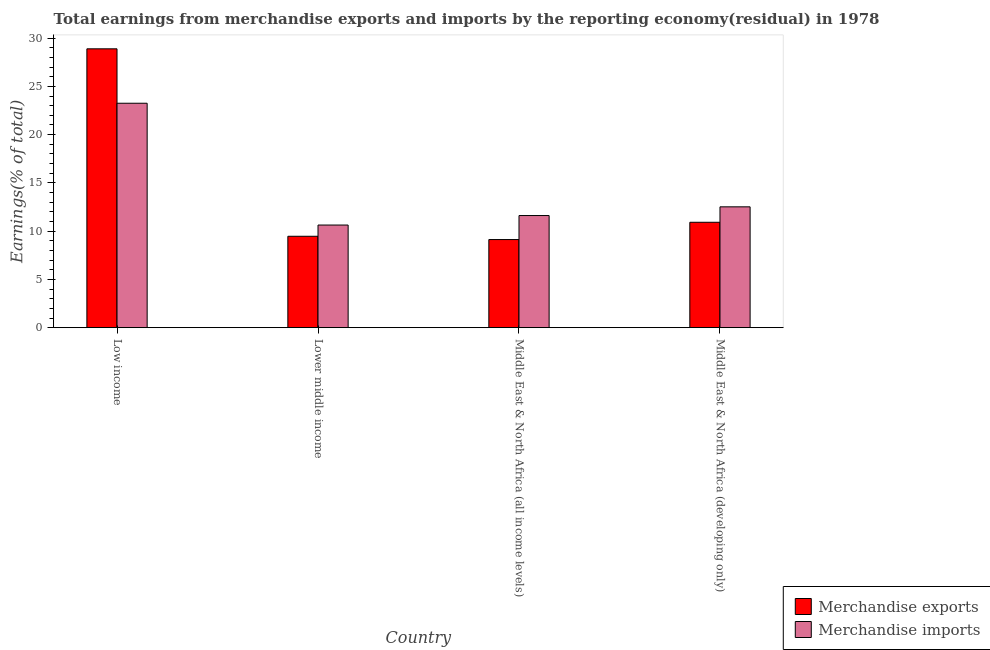How many different coloured bars are there?
Offer a terse response. 2. Are the number of bars per tick equal to the number of legend labels?
Your answer should be compact. Yes. How many bars are there on the 4th tick from the left?
Offer a very short reply. 2. How many bars are there on the 2nd tick from the right?
Your response must be concise. 2. What is the label of the 3rd group of bars from the left?
Your answer should be compact. Middle East & North Africa (all income levels). In how many cases, is the number of bars for a given country not equal to the number of legend labels?
Provide a succinct answer. 0. What is the earnings from merchandise exports in Middle East & North Africa (all income levels)?
Offer a very short reply. 9.13. Across all countries, what is the maximum earnings from merchandise exports?
Keep it short and to the point. 28.89. Across all countries, what is the minimum earnings from merchandise exports?
Your answer should be compact. 9.13. In which country was the earnings from merchandise imports maximum?
Your answer should be compact. Low income. In which country was the earnings from merchandise exports minimum?
Offer a very short reply. Middle East & North Africa (all income levels). What is the total earnings from merchandise imports in the graph?
Keep it short and to the point. 58.02. What is the difference between the earnings from merchandise exports in Lower middle income and that in Middle East & North Africa (developing only)?
Provide a short and direct response. -1.45. What is the difference between the earnings from merchandise imports in Lower middle income and the earnings from merchandise exports in Middle East & North Africa (all income levels)?
Ensure brevity in your answer.  1.5. What is the average earnings from merchandise exports per country?
Your response must be concise. 14.6. What is the difference between the earnings from merchandise imports and earnings from merchandise exports in Lower middle income?
Ensure brevity in your answer.  1.16. What is the ratio of the earnings from merchandise exports in Middle East & North Africa (all income levels) to that in Middle East & North Africa (developing only)?
Your answer should be compact. 0.84. Is the difference between the earnings from merchandise imports in Lower middle income and Middle East & North Africa (all income levels) greater than the difference between the earnings from merchandise exports in Lower middle income and Middle East & North Africa (all income levels)?
Your answer should be very brief. No. What is the difference between the highest and the second highest earnings from merchandise exports?
Your answer should be compact. 17.97. What is the difference between the highest and the lowest earnings from merchandise imports?
Offer a terse response. 12.62. What does the 2nd bar from the left in Middle East & North Africa (all income levels) represents?
Provide a short and direct response. Merchandise imports. What does the 1st bar from the right in Middle East & North Africa (all income levels) represents?
Give a very brief answer. Merchandise imports. Are the values on the major ticks of Y-axis written in scientific E-notation?
Keep it short and to the point. No. Does the graph contain grids?
Provide a short and direct response. No. Where does the legend appear in the graph?
Give a very brief answer. Bottom right. What is the title of the graph?
Provide a short and direct response. Total earnings from merchandise exports and imports by the reporting economy(residual) in 1978. Does "Agricultural land" appear as one of the legend labels in the graph?
Provide a succinct answer. No. What is the label or title of the X-axis?
Give a very brief answer. Country. What is the label or title of the Y-axis?
Offer a terse response. Earnings(% of total). What is the Earnings(% of total) in Merchandise exports in Low income?
Give a very brief answer. 28.89. What is the Earnings(% of total) of Merchandise imports in Low income?
Make the answer very short. 23.25. What is the Earnings(% of total) in Merchandise exports in Lower middle income?
Keep it short and to the point. 9.47. What is the Earnings(% of total) of Merchandise imports in Lower middle income?
Provide a succinct answer. 10.63. What is the Earnings(% of total) in Merchandise exports in Middle East & North Africa (all income levels)?
Offer a very short reply. 9.13. What is the Earnings(% of total) in Merchandise imports in Middle East & North Africa (all income levels)?
Provide a succinct answer. 11.62. What is the Earnings(% of total) of Merchandise exports in Middle East & North Africa (developing only)?
Provide a short and direct response. 10.92. What is the Earnings(% of total) in Merchandise imports in Middle East & North Africa (developing only)?
Your answer should be very brief. 12.52. Across all countries, what is the maximum Earnings(% of total) in Merchandise exports?
Provide a succinct answer. 28.89. Across all countries, what is the maximum Earnings(% of total) in Merchandise imports?
Your response must be concise. 23.25. Across all countries, what is the minimum Earnings(% of total) in Merchandise exports?
Give a very brief answer. 9.13. Across all countries, what is the minimum Earnings(% of total) of Merchandise imports?
Your response must be concise. 10.63. What is the total Earnings(% of total) of Merchandise exports in the graph?
Make the answer very short. 58.41. What is the total Earnings(% of total) of Merchandise imports in the graph?
Provide a short and direct response. 58.02. What is the difference between the Earnings(% of total) of Merchandise exports in Low income and that in Lower middle income?
Your response must be concise. 19.42. What is the difference between the Earnings(% of total) of Merchandise imports in Low income and that in Lower middle income?
Offer a terse response. 12.62. What is the difference between the Earnings(% of total) of Merchandise exports in Low income and that in Middle East & North Africa (all income levels)?
Offer a very short reply. 19.76. What is the difference between the Earnings(% of total) of Merchandise imports in Low income and that in Middle East & North Africa (all income levels)?
Offer a very short reply. 11.63. What is the difference between the Earnings(% of total) of Merchandise exports in Low income and that in Middle East & North Africa (developing only)?
Your answer should be very brief. 17.97. What is the difference between the Earnings(% of total) in Merchandise imports in Low income and that in Middle East & North Africa (developing only)?
Make the answer very short. 10.73. What is the difference between the Earnings(% of total) in Merchandise exports in Lower middle income and that in Middle East & North Africa (all income levels)?
Your answer should be compact. 0.34. What is the difference between the Earnings(% of total) of Merchandise imports in Lower middle income and that in Middle East & North Africa (all income levels)?
Offer a terse response. -0.98. What is the difference between the Earnings(% of total) in Merchandise exports in Lower middle income and that in Middle East & North Africa (developing only)?
Give a very brief answer. -1.45. What is the difference between the Earnings(% of total) in Merchandise imports in Lower middle income and that in Middle East & North Africa (developing only)?
Give a very brief answer. -1.89. What is the difference between the Earnings(% of total) in Merchandise exports in Middle East & North Africa (all income levels) and that in Middle East & North Africa (developing only)?
Your response must be concise. -1.79. What is the difference between the Earnings(% of total) of Merchandise imports in Middle East & North Africa (all income levels) and that in Middle East & North Africa (developing only)?
Keep it short and to the point. -0.9. What is the difference between the Earnings(% of total) of Merchandise exports in Low income and the Earnings(% of total) of Merchandise imports in Lower middle income?
Your answer should be compact. 18.26. What is the difference between the Earnings(% of total) of Merchandise exports in Low income and the Earnings(% of total) of Merchandise imports in Middle East & North Africa (all income levels)?
Your answer should be very brief. 17.27. What is the difference between the Earnings(% of total) of Merchandise exports in Low income and the Earnings(% of total) of Merchandise imports in Middle East & North Africa (developing only)?
Give a very brief answer. 16.37. What is the difference between the Earnings(% of total) in Merchandise exports in Lower middle income and the Earnings(% of total) in Merchandise imports in Middle East & North Africa (all income levels)?
Offer a terse response. -2.15. What is the difference between the Earnings(% of total) of Merchandise exports in Lower middle income and the Earnings(% of total) of Merchandise imports in Middle East & North Africa (developing only)?
Offer a very short reply. -3.05. What is the difference between the Earnings(% of total) in Merchandise exports in Middle East & North Africa (all income levels) and the Earnings(% of total) in Merchandise imports in Middle East & North Africa (developing only)?
Provide a succinct answer. -3.39. What is the average Earnings(% of total) of Merchandise exports per country?
Your answer should be very brief. 14.6. What is the average Earnings(% of total) of Merchandise imports per country?
Give a very brief answer. 14.51. What is the difference between the Earnings(% of total) of Merchandise exports and Earnings(% of total) of Merchandise imports in Low income?
Your response must be concise. 5.64. What is the difference between the Earnings(% of total) of Merchandise exports and Earnings(% of total) of Merchandise imports in Lower middle income?
Offer a terse response. -1.16. What is the difference between the Earnings(% of total) of Merchandise exports and Earnings(% of total) of Merchandise imports in Middle East & North Africa (all income levels)?
Ensure brevity in your answer.  -2.49. What is the ratio of the Earnings(% of total) in Merchandise exports in Low income to that in Lower middle income?
Offer a terse response. 3.05. What is the ratio of the Earnings(% of total) in Merchandise imports in Low income to that in Lower middle income?
Offer a very short reply. 2.19. What is the ratio of the Earnings(% of total) in Merchandise exports in Low income to that in Middle East & North Africa (all income levels)?
Provide a short and direct response. 3.17. What is the ratio of the Earnings(% of total) of Merchandise imports in Low income to that in Middle East & North Africa (all income levels)?
Your response must be concise. 2. What is the ratio of the Earnings(% of total) in Merchandise exports in Low income to that in Middle East & North Africa (developing only)?
Your answer should be compact. 2.65. What is the ratio of the Earnings(% of total) in Merchandise imports in Low income to that in Middle East & North Africa (developing only)?
Offer a terse response. 1.86. What is the ratio of the Earnings(% of total) of Merchandise exports in Lower middle income to that in Middle East & North Africa (all income levels)?
Provide a succinct answer. 1.04. What is the ratio of the Earnings(% of total) in Merchandise imports in Lower middle income to that in Middle East & North Africa (all income levels)?
Give a very brief answer. 0.92. What is the ratio of the Earnings(% of total) in Merchandise exports in Lower middle income to that in Middle East & North Africa (developing only)?
Give a very brief answer. 0.87. What is the ratio of the Earnings(% of total) in Merchandise imports in Lower middle income to that in Middle East & North Africa (developing only)?
Offer a very short reply. 0.85. What is the ratio of the Earnings(% of total) of Merchandise exports in Middle East & North Africa (all income levels) to that in Middle East & North Africa (developing only)?
Your answer should be very brief. 0.84. What is the ratio of the Earnings(% of total) of Merchandise imports in Middle East & North Africa (all income levels) to that in Middle East & North Africa (developing only)?
Your answer should be compact. 0.93. What is the difference between the highest and the second highest Earnings(% of total) in Merchandise exports?
Your answer should be very brief. 17.97. What is the difference between the highest and the second highest Earnings(% of total) of Merchandise imports?
Provide a short and direct response. 10.73. What is the difference between the highest and the lowest Earnings(% of total) in Merchandise exports?
Give a very brief answer. 19.76. What is the difference between the highest and the lowest Earnings(% of total) in Merchandise imports?
Offer a terse response. 12.62. 